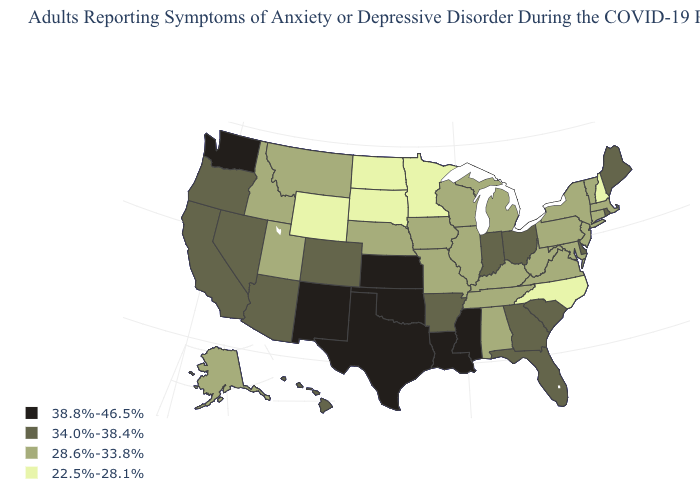What is the lowest value in states that border North Dakota?
Concise answer only. 22.5%-28.1%. Does New Hampshire have a lower value than North Carolina?
Give a very brief answer. No. Name the states that have a value in the range 22.5%-28.1%?
Write a very short answer. Minnesota, New Hampshire, North Carolina, North Dakota, South Dakota, Wyoming. Does the map have missing data?
Keep it brief. No. Does Colorado have the same value as Arkansas?
Concise answer only. Yes. Does Missouri have a higher value than Wyoming?
Concise answer only. Yes. Name the states that have a value in the range 22.5%-28.1%?
Short answer required. Minnesota, New Hampshire, North Carolina, North Dakota, South Dakota, Wyoming. Does Arkansas have a lower value than Kansas?
Give a very brief answer. Yes. What is the highest value in states that border Colorado?
Answer briefly. 38.8%-46.5%. Name the states that have a value in the range 34.0%-38.4%?
Answer briefly. Arizona, Arkansas, California, Colorado, Delaware, Florida, Georgia, Hawaii, Indiana, Maine, Nevada, Ohio, Oregon, Rhode Island, South Carolina. How many symbols are there in the legend?
Keep it brief. 4. Does North Dakota have the lowest value in the USA?
Short answer required. Yes. Which states have the highest value in the USA?
Keep it brief. Kansas, Louisiana, Mississippi, New Mexico, Oklahoma, Texas, Washington. What is the value of Colorado?
Short answer required. 34.0%-38.4%. Does Washington have the highest value in the USA?
Quick response, please. Yes. 